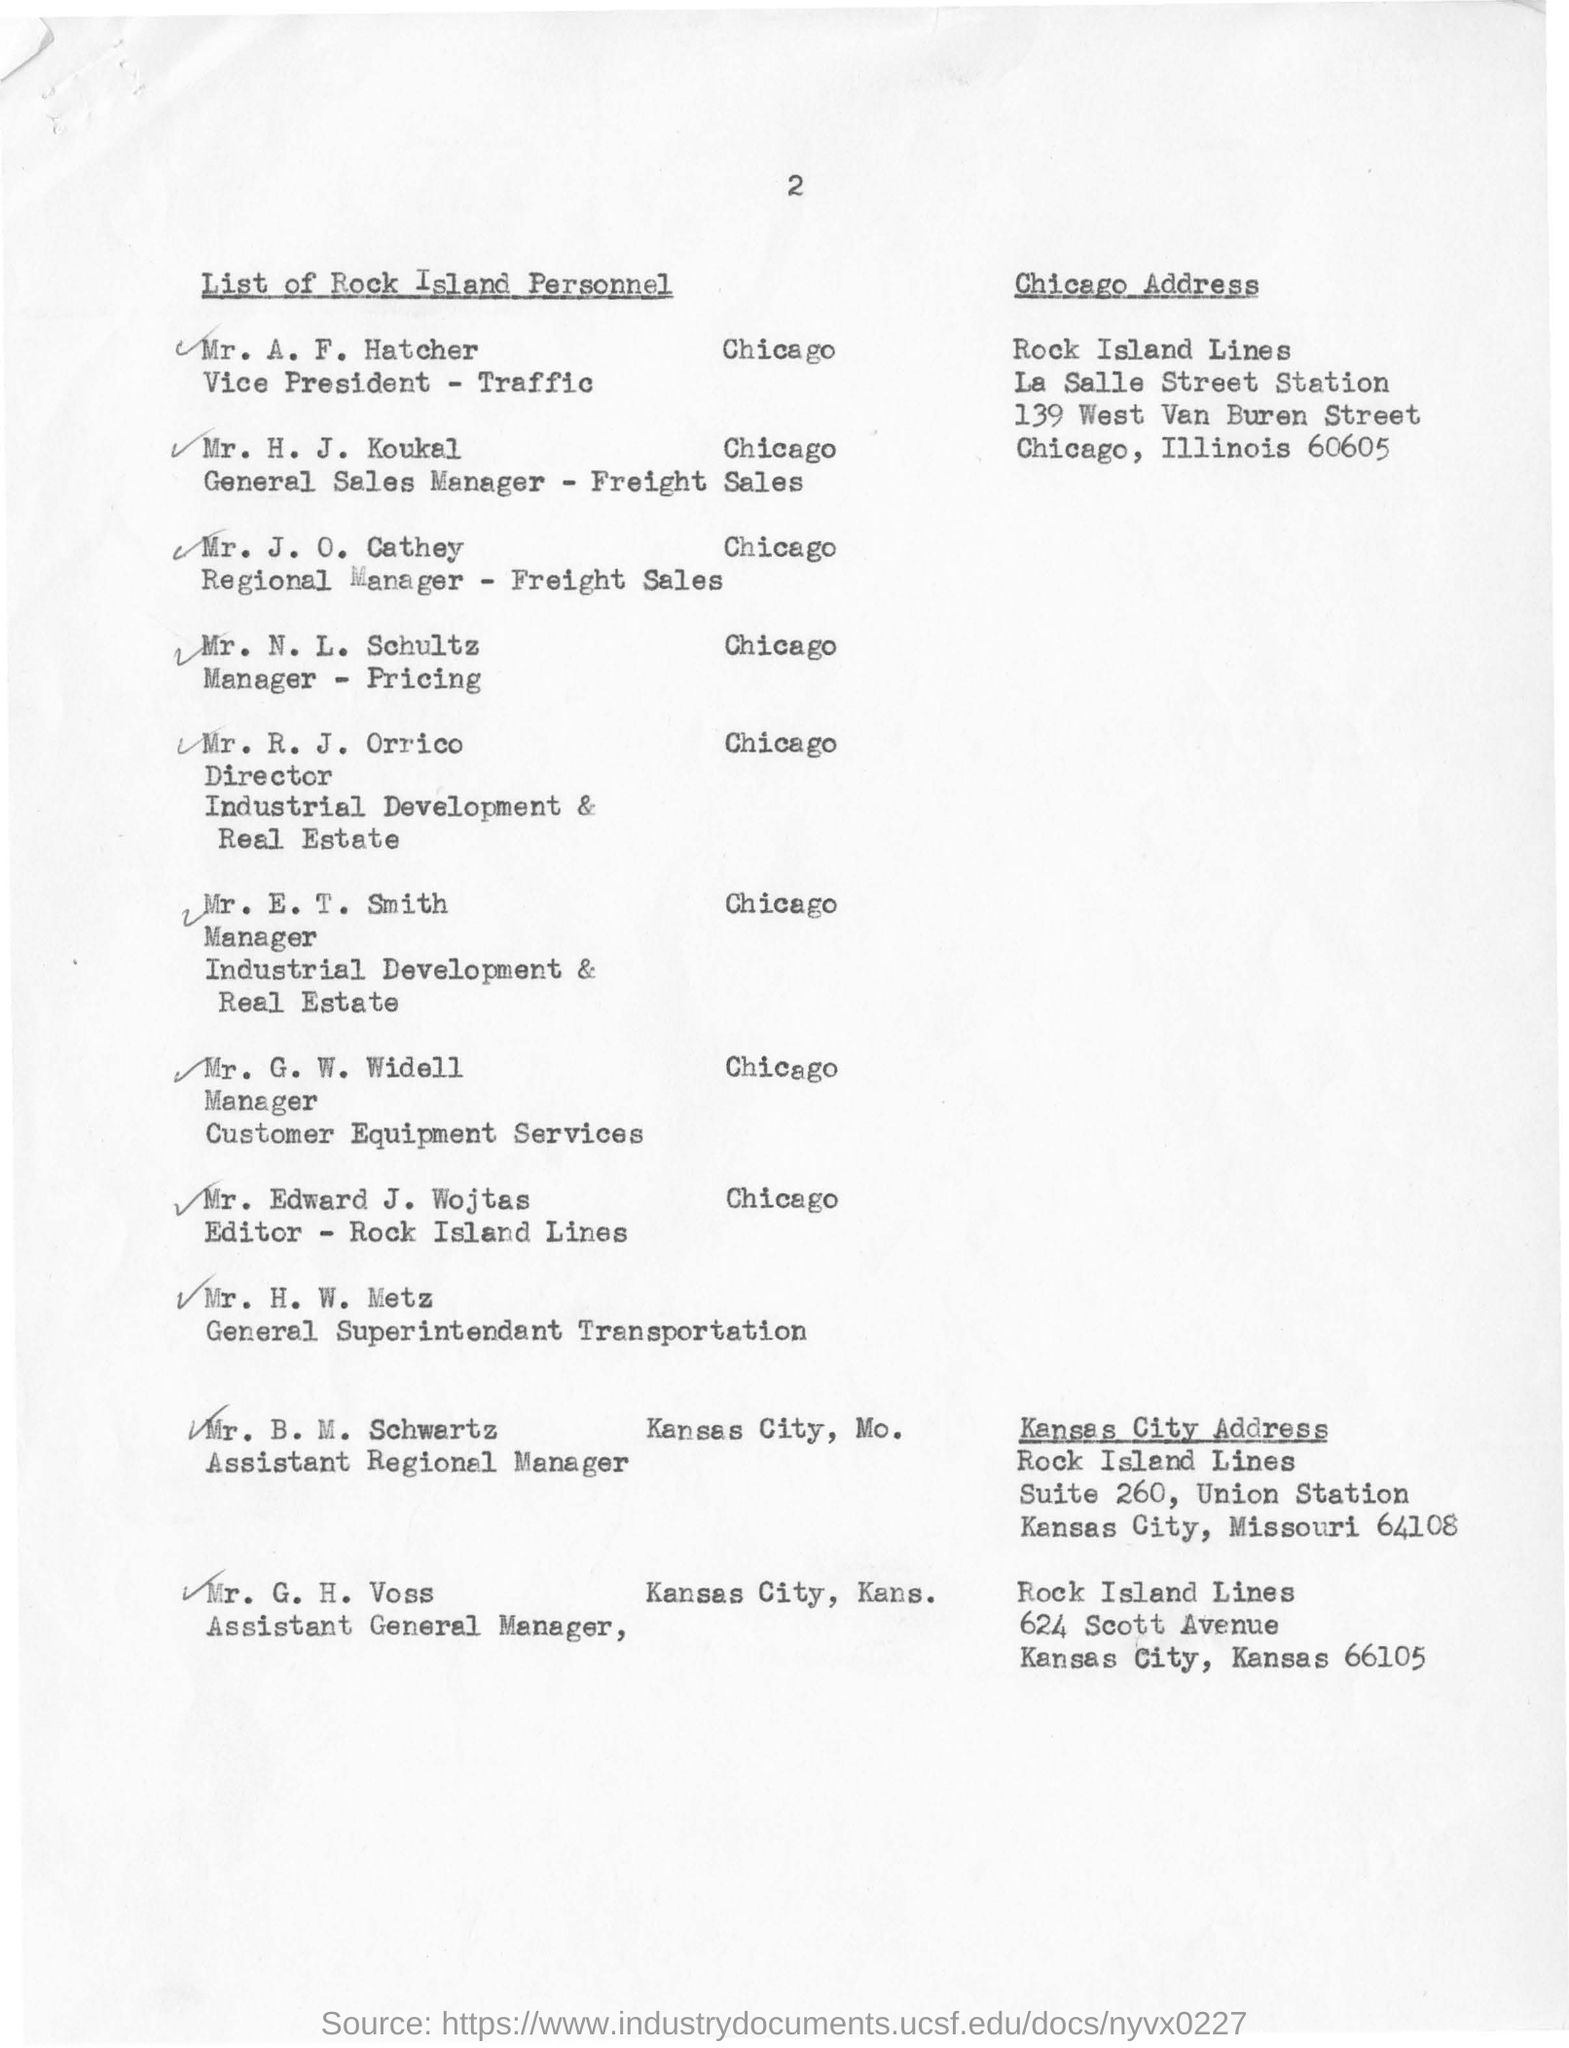Who is vice president-traffic
Provide a short and direct response. Mr. A. F. Hatcher. Designation of Mr H J Koukal
Your response must be concise. General Sales Manager - Freight Sales. Director of Industrial Development & Real Estate
Your response must be concise. Mr. R. J. Orrico. Designation of Mr N L Schultz
Ensure brevity in your answer.  Manager - Pricing. 